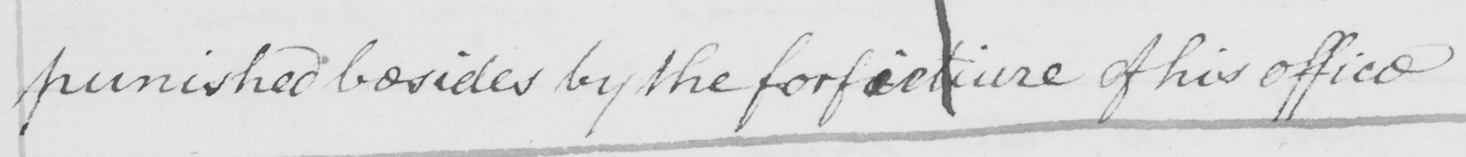Transcribe the text shown in this historical manuscript line. punished besides by the forfieture of his office 